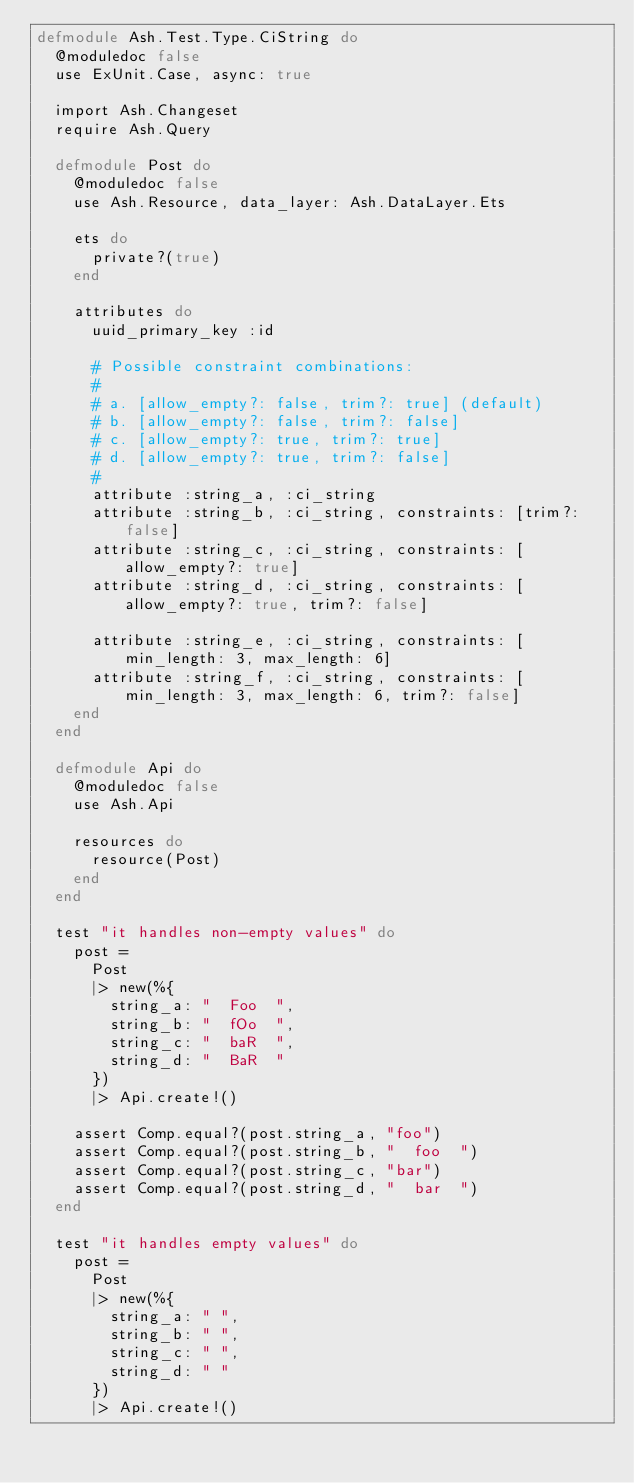<code> <loc_0><loc_0><loc_500><loc_500><_Elixir_>defmodule Ash.Test.Type.CiString do
  @moduledoc false
  use ExUnit.Case, async: true

  import Ash.Changeset
  require Ash.Query

  defmodule Post do
    @moduledoc false
    use Ash.Resource, data_layer: Ash.DataLayer.Ets

    ets do
      private?(true)
    end

    attributes do
      uuid_primary_key :id

      # Possible constraint combinations:
      #
      # a. [allow_empty?: false, trim?: true] (default)
      # b. [allow_empty?: false, trim?: false]
      # c. [allow_empty?: true, trim?: true]
      # d. [allow_empty?: true, trim?: false]
      #
      attribute :string_a, :ci_string
      attribute :string_b, :ci_string, constraints: [trim?: false]
      attribute :string_c, :ci_string, constraints: [allow_empty?: true]
      attribute :string_d, :ci_string, constraints: [allow_empty?: true, trim?: false]

      attribute :string_e, :ci_string, constraints: [min_length: 3, max_length: 6]
      attribute :string_f, :ci_string, constraints: [min_length: 3, max_length: 6, trim?: false]
    end
  end

  defmodule Api do
    @moduledoc false
    use Ash.Api

    resources do
      resource(Post)
    end
  end

  test "it handles non-empty values" do
    post =
      Post
      |> new(%{
        string_a: "  Foo  ",
        string_b: "  fOo  ",
        string_c: "  baR  ",
        string_d: "  BaR  "
      })
      |> Api.create!()

    assert Comp.equal?(post.string_a, "foo")
    assert Comp.equal?(post.string_b, "  foo  ")
    assert Comp.equal?(post.string_c, "bar")
    assert Comp.equal?(post.string_d, "  bar  ")
  end

  test "it handles empty values" do
    post =
      Post
      |> new(%{
        string_a: " ",
        string_b: " ",
        string_c: " ",
        string_d: " "
      })
      |> Api.create!()
</code> 